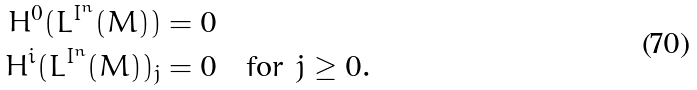<formula> <loc_0><loc_0><loc_500><loc_500>H ^ { 0 } ( L ^ { I ^ { n } } ( M ) ) & = 0 \\ H ^ { i } ( L ^ { I ^ { n } } ( M ) ) _ { j } & = 0 \quad \text {for} \ j \geq 0 .</formula> 